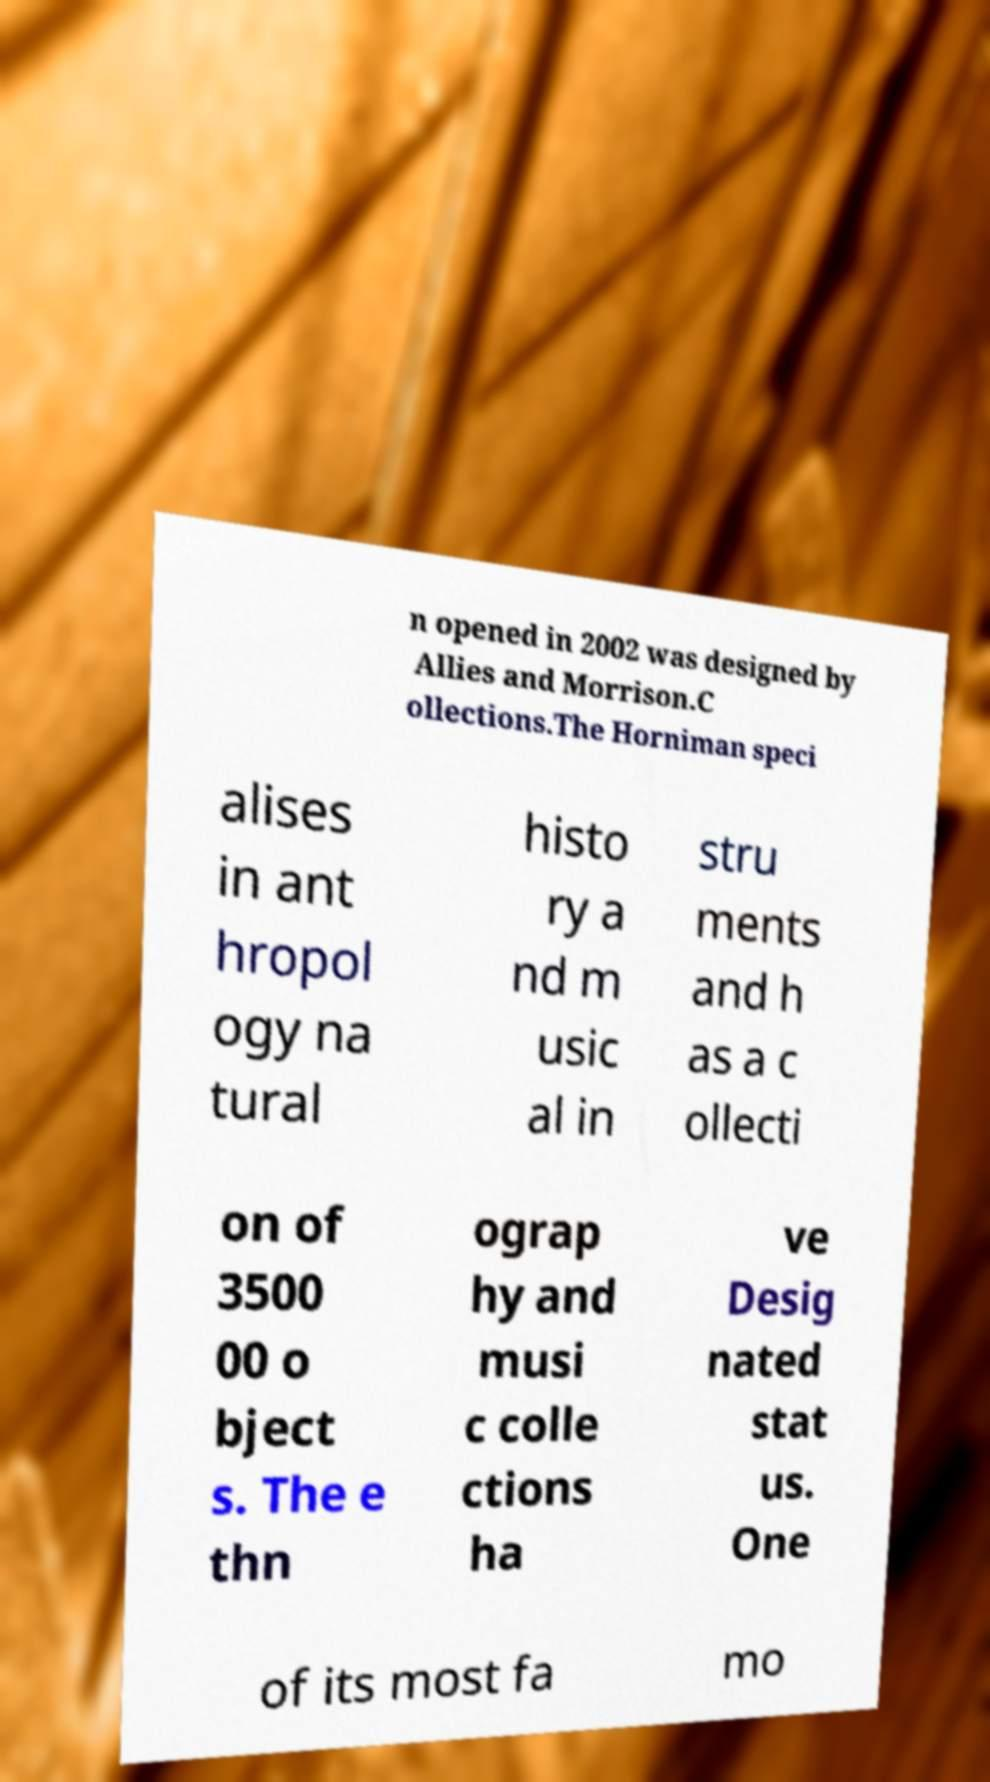Please identify and transcribe the text found in this image. n opened in 2002 was designed by Allies and Morrison.C ollections.The Horniman speci alises in ant hropol ogy na tural histo ry a nd m usic al in stru ments and h as a c ollecti on of 3500 00 o bject s. The e thn ograp hy and musi c colle ctions ha ve Desig nated stat us. One of its most fa mo 